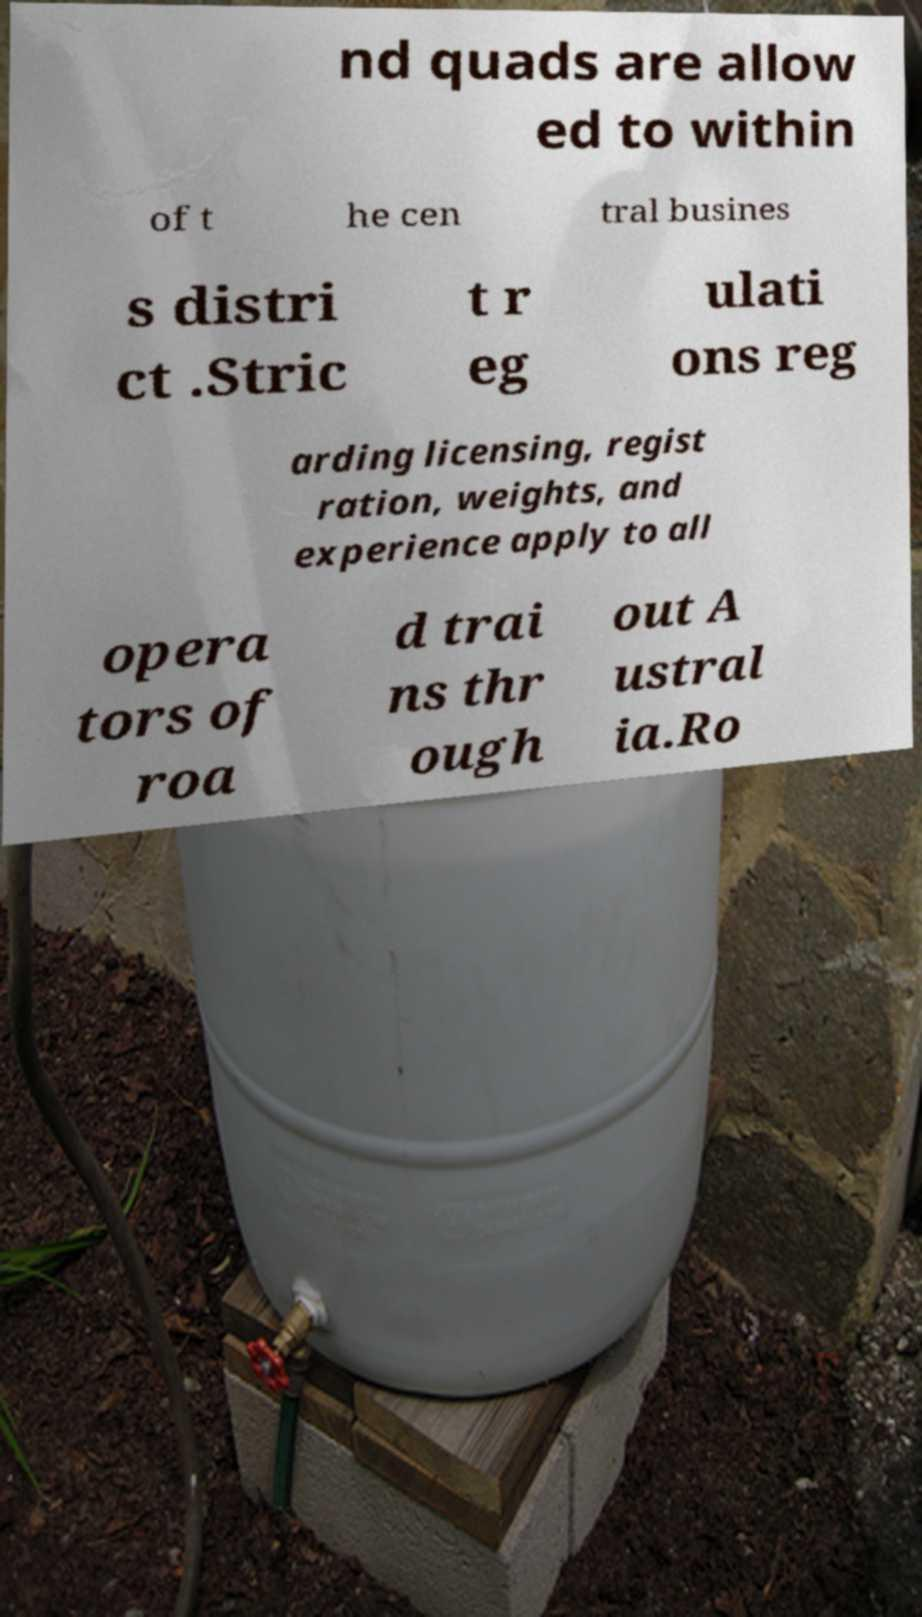For documentation purposes, I need the text within this image transcribed. Could you provide that? nd quads are allow ed to within of t he cen tral busines s distri ct .Stric t r eg ulati ons reg arding licensing, regist ration, weights, and experience apply to all opera tors of roa d trai ns thr ough out A ustral ia.Ro 